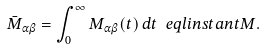Convert formula to latex. <formula><loc_0><loc_0><loc_500><loc_500>\bar { M } _ { \alpha \beta } = \int _ { 0 } ^ { \infty } M _ { \alpha \beta } ( t ) \, d t \ e q l { i n s t a n t M } .</formula> 